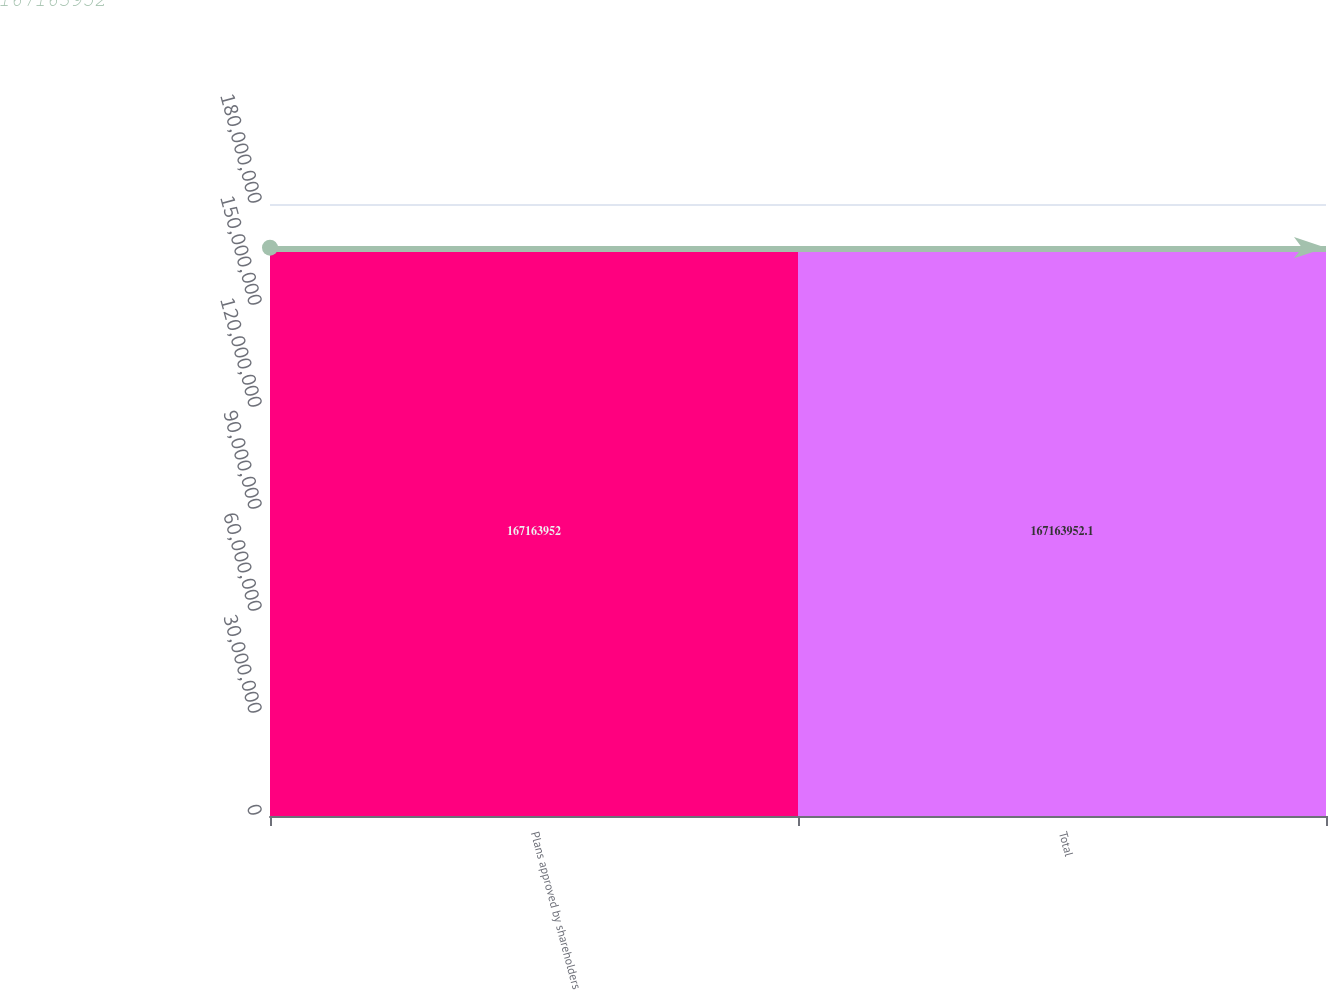<chart> <loc_0><loc_0><loc_500><loc_500><bar_chart><fcel>Plans approved by shareholders<fcel>Total<nl><fcel>1.67164e+08<fcel>1.67164e+08<nl></chart> 